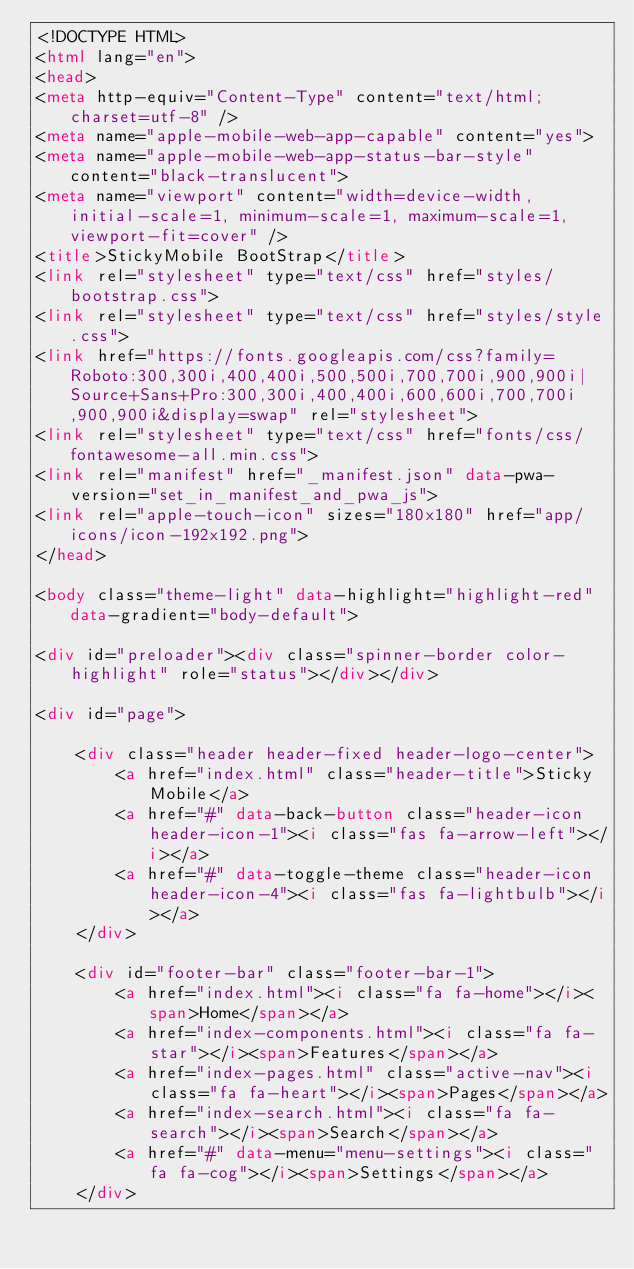<code> <loc_0><loc_0><loc_500><loc_500><_HTML_><!DOCTYPE HTML>
<html lang="en">
<head>
<meta http-equiv="Content-Type" content="text/html; charset=utf-8" />
<meta name="apple-mobile-web-app-capable" content="yes">
<meta name="apple-mobile-web-app-status-bar-style" content="black-translucent">
<meta name="viewport" content="width=device-width, initial-scale=1, minimum-scale=1, maximum-scale=1, viewport-fit=cover" />
<title>StickyMobile BootStrap</title>
<link rel="stylesheet" type="text/css" href="styles/bootstrap.css">
<link rel="stylesheet" type="text/css" href="styles/style.css">
<link href="https://fonts.googleapis.com/css?family=Roboto:300,300i,400,400i,500,500i,700,700i,900,900i|Source+Sans+Pro:300,300i,400,400i,600,600i,700,700i,900,900i&display=swap" rel="stylesheet">
<link rel="stylesheet" type="text/css" href="fonts/css/fontawesome-all.min.css">
<link rel="manifest" href="_manifest.json" data-pwa-version="set_in_manifest_and_pwa_js">
<link rel="apple-touch-icon" sizes="180x180" href="app/icons/icon-192x192.png">
</head>

<body class="theme-light" data-highlight="highlight-red" data-gradient="body-default">

<div id="preloader"><div class="spinner-border color-highlight" role="status"></div></div>

<div id="page">

    <div class="header header-fixed header-logo-center">
        <a href="index.html" class="header-title">Sticky Mobile</a>
        <a href="#" data-back-button class="header-icon header-icon-1"><i class="fas fa-arrow-left"></i></a>
        <a href="#" data-toggle-theme class="header-icon header-icon-4"><i class="fas fa-lightbulb"></i></a>
    </div>

    <div id="footer-bar" class="footer-bar-1">
        <a href="index.html"><i class="fa fa-home"></i><span>Home</span></a>
        <a href="index-components.html"><i class="fa fa-star"></i><span>Features</span></a>
        <a href="index-pages.html" class="active-nav"><i class="fa fa-heart"></i><span>Pages</span></a>
        <a href="index-search.html"><i class="fa fa-search"></i><span>Search</span></a>
        <a href="#" data-menu="menu-settings"><i class="fa fa-cog"></i><span>Settings</span></a>
    </div>
</code> 